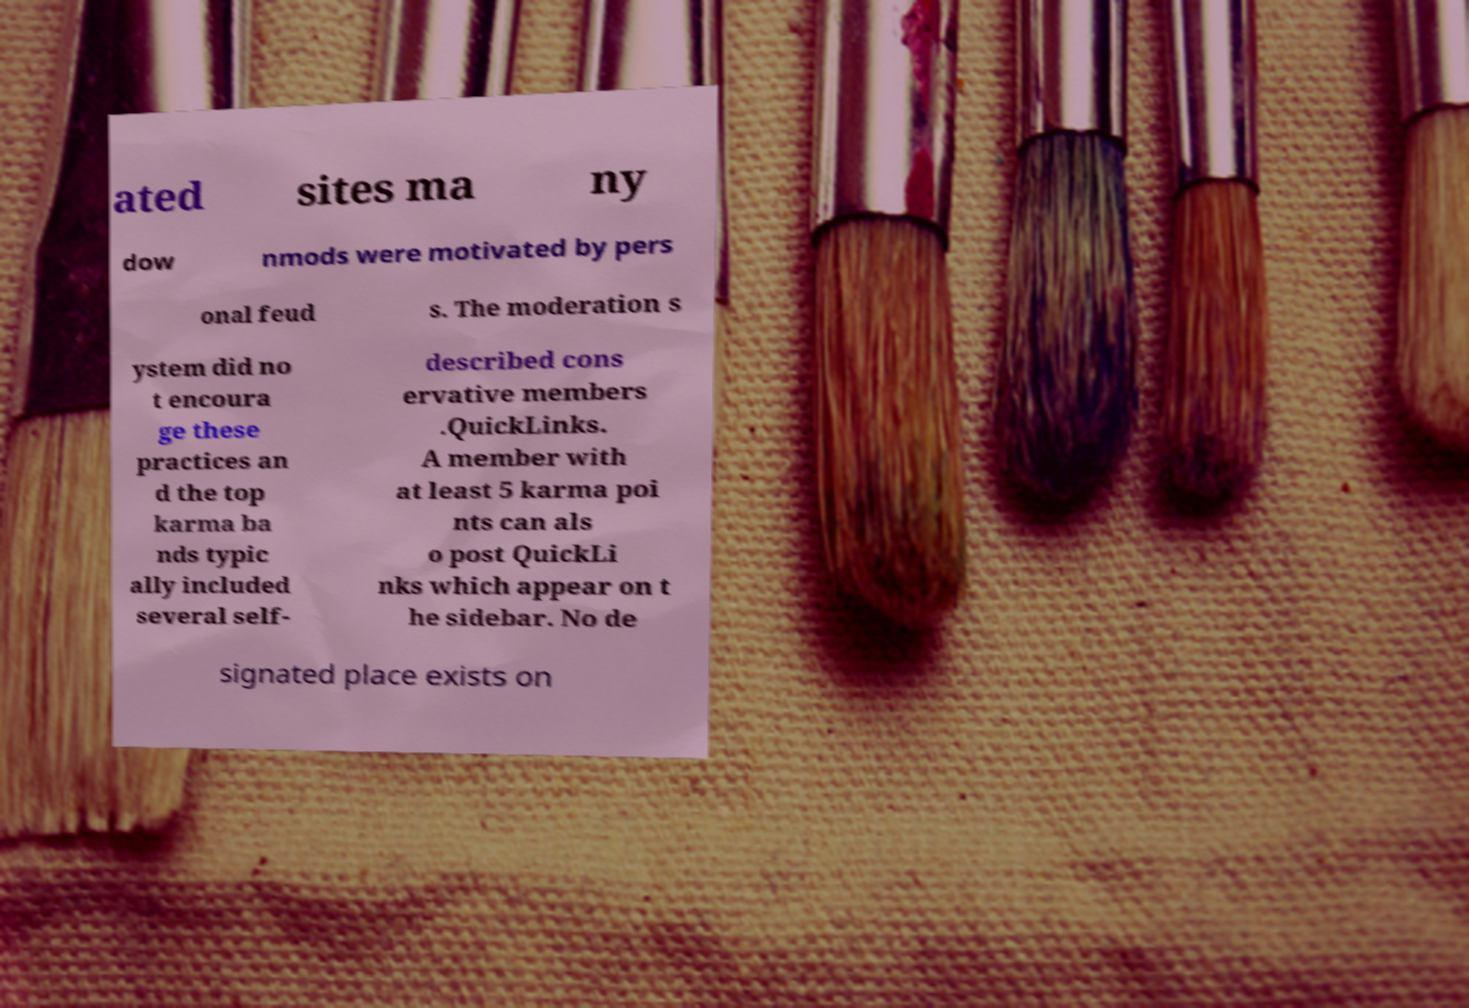Could you extract and type out the text from this image? ated sites ma ny dow nmods were motivated by pers onal feud s. The moderation s ystem did no t encoura ge these practices an d the top karma ba nds typic ally included several self- described cons ervative members .QuickLinks. A member with at least 5 karma poi nts can als o post QuickLi nks which appear on t he sidebar. No de signated place exists on 